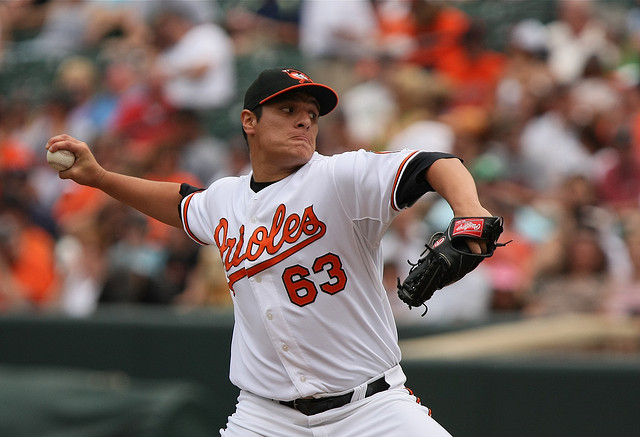<image>Did the man hit the ball? I don't know if the man hit the ball. What position does this guy play? I don't know the exact position this person plays. It seems they might be a pitcher, but it is not certain. Did the man hit the ball? I don't know if the man hit the ball. It seems like he did not hit the ball according to the answers. What position does this guy play? I am not sure what position this guy plays. It can be pitcher or outfield. 